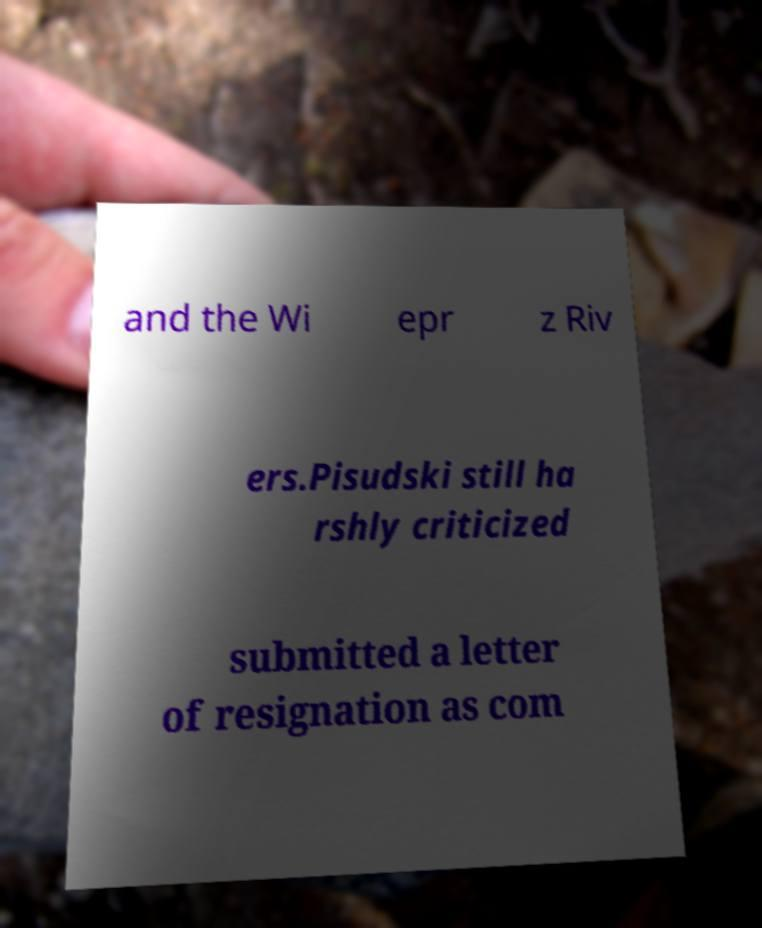What messages or text are displayed in this image? I need them in a readable, typed format. and the Wi epr z Riv ers.Pisudski still ha rshly criticized submitted a letter of resignation as com 